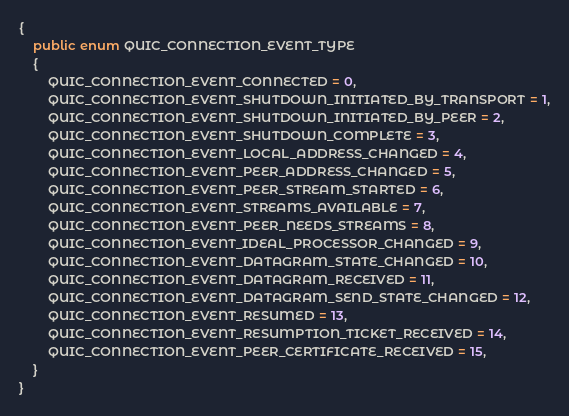Convert code to text. <code><loc_0><loc_0><loc_500><loc_500><_C#_>{
    public enum QUIC_CONNECTION_EVENT_TYPE
    {
        QUIC_CONNECTION_EVENT_CONNECTED = 0,
        QUIC_CONNECTION_EVENT_SHUTDOWN_INITIATED_BY_TRANSPORT = 1,
        QUIC_CONNECTION_EVENT_SHUTDOWN_INITIATED_BY_PEER = 2,
        QUIC_CONNECTION_EVENT_SHUTDOWN_COMPLETE = 3,
        QUIC_CONNECTION_EVENT_LOCAL_ADDRESS_CHANGED = 4,
        QUIC_CONNECTION_EVENT_PEER_ADDRESS_CHANGED = 5,
        QUIC_CONNECTION_EVENT_PEER_STREAM_STARTED = 6,
        QUIC_CONNECTION_EVENT_STREAMS_AVAILABLE = 7,
        QUIC_CONNECTION_EVENT_PEER_NEEDS_STREAMS = 8,
        QUIC_CONNECTION_EVENT_IDEAL_PROCESSOR_CHANGED = 9,
        QUIC_CONNECTION_EVENT_DATAGRAM_STATE_CHANGED = 10,
        QUIC_CONNECTION_EVENT_DATAGRAM_RECEIVED = 11,
        QUIC_CONNECTION_EVENT_DATAGRAM_SEND_STATE_CHANGED = 12,
        QUIC_CONNECTION_EVENT_RESUMED = 13,
        QUIC_CONNECTION_EVENT_RESUMPTION_TICKET_RECEIVED = 14,
        QUIC_CONNECTION_EVENT_PEER_CERTIFICATE_RECEIVED = 15,
    }
}
</code> 